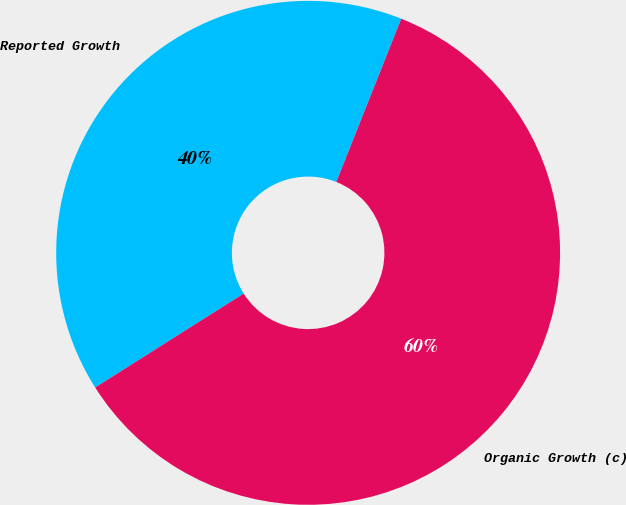<chart> <loc_0><loc_0><loc_500><loc_500><pie_chart><fcel>Reported Growth<fcel>Organic Growth (c)<nl><fcel>40.0%<fcel>60.0%<nl></chart> 